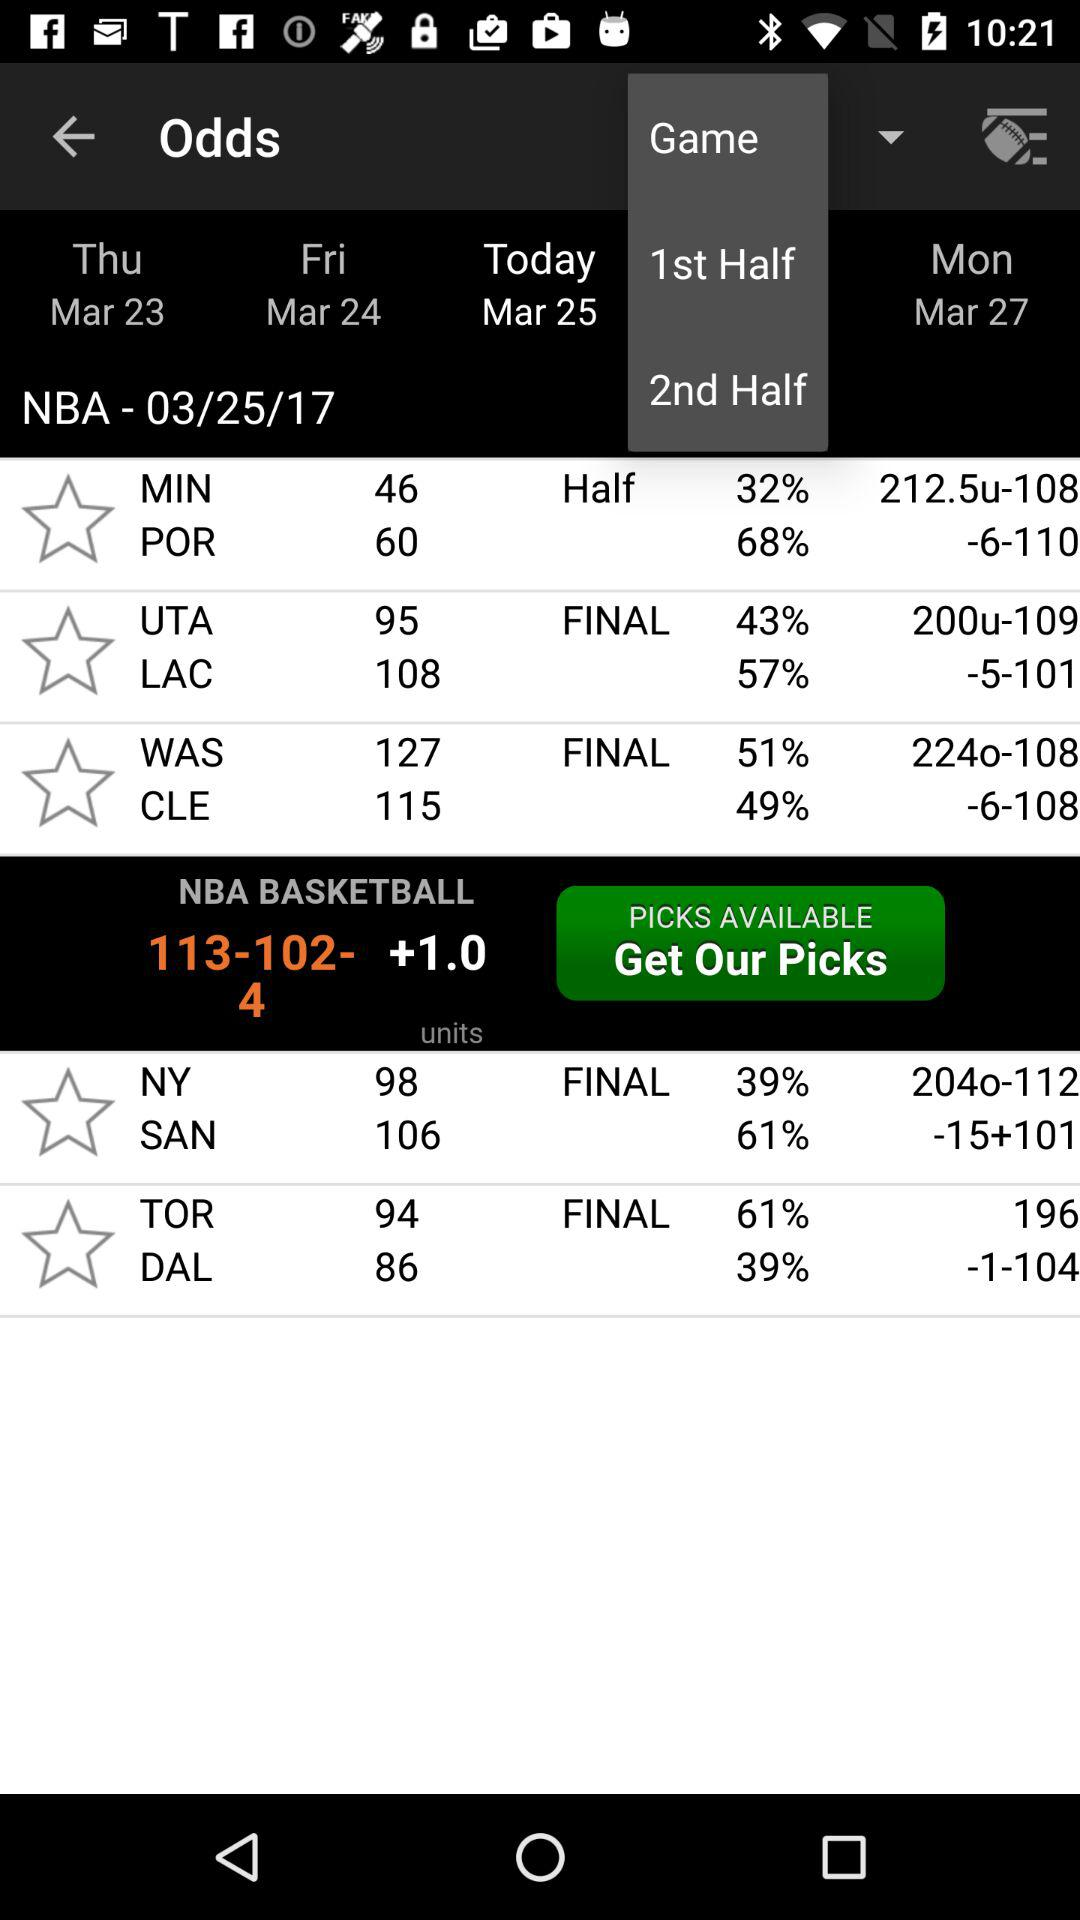How many more points did the MIN team score in the first half than the POR team?
Answer the question using a single word or phrase. 14 